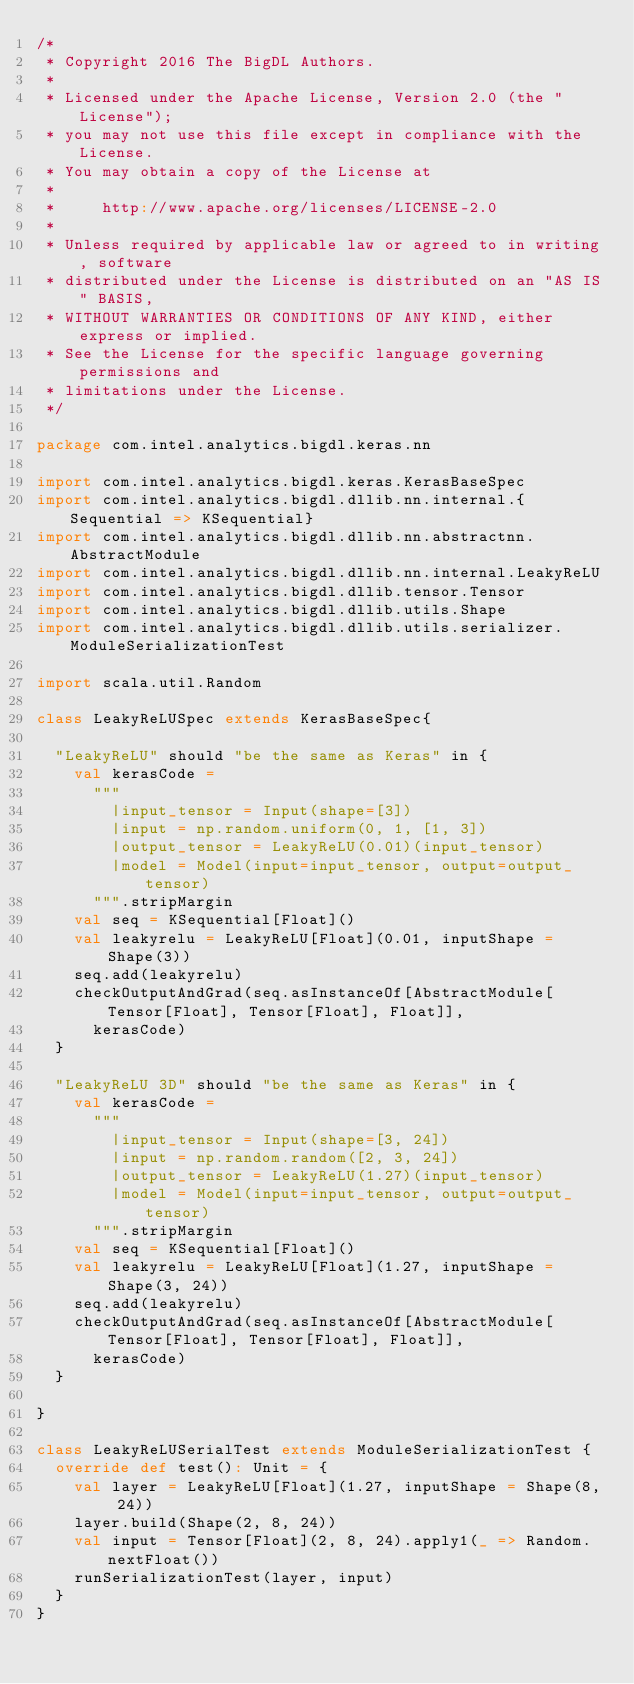<code> <loc_0><loc_0><loc_500><loc_500><_Scala_>/*
 * Copyright 2016 The BigDL Authors.
 *
 * Licensed under the Apache License, Version 2.0 (the "License");
 * you may not use this file except in compliance with the License.
 * You may obtain a copy of the License at
 *
 *     http://www.apache.org/licenses/LICENSE-2.0
 *
 * Unless required by applicable law or agreed to in writing, software
 * distributed under the License is distributed on an "AS IS" BASIS,
 * WITHOUT WARRANTIES OR CONDITIONS OF ANY KIND, either express or implied.
 * See the License for the specific language governing permissions and
 * limitations under the License.
 */

package com.intel.analytics.bigdl.keras.nn

import com.intel.analytics.bigdl.keras.KerasBaseSpec
import com.intel.analytics.bigdl.dllib.nn.internal.{Sequential => KSequential}
import com.intel.analytics.bigdl.dllib.nn.abstractnn.AbstractModule
import com.intel.analytics.bigdl.dllib.nn.internal.LeakyReLU
import com.intel.analytics.bigdl.dllib.tensor.Tensor
import com.intel.analytics.bigdl.dllib.utils.Shape
import com.intel.analytics.bigdl.dllib.utils.serializer.ModuleSerializationTest

import scala.util.Random

class LeakyReLUSpec extends KerasBaseSpec{

  "LeakyReLU" should "be the same as Keras" in {
    val kerasCode =
      """
        |input_tensor = Input(shape=[3])
        |input = np.random.uniform(0, 1, [1, 3])
        |output_tensor = LeakyReLU(0.01)(input_tensor)
        |model = Model(input=input_tensor, output=output_tensor)
      """.stripMargin
    val seq = KSequential[Float]()
    val leakyrelu = LeakyReLU[Float](0.01, inputShape = Shape(3))
    seq.add(leakyrelu)
    checkOutputAndGrad(seq.asInstanceOf[AbstractModule[Tensor[Float], Tensor[Float], Float]],
      kerasCode)
  }

  "LeakyReLU 3D" should "be the same as Keras" in {
    val kerasCode =
      """
        |input_tensor = Input(shape=[3, 24])
        |input = np.random.random([2, 3, 24])
        |output_tensor = LeakyReLU(1.27)(input_tensor)
        |model = Model(input=input_tensor, output=output_tensor)
      """.stripMargin
    val seq = KSequential[Float]()
    val leakyrelu = LeakyReLU[Float](1.27, inputShape = Shape(3, 24))
    seq.add(leakyrelu)
    checkOutputAndGrad(seq.asInstanceOf[AbstractModule[Tensor[Float], Tensor[Float], Float]],
      kerasCode)
  }

}

class LeakyReLUSerialTest extends ModuleSerializationTest {
  override def test(): Unit = {
    val layer = LeakyReLU[Float](1.27, inputShape = Shape(8, 24))
    layer.build(Shape(2, 8, 24))
    val input = Tensor[Float](2, 8, 24).apply1(_ => Random.nextFloat())
    runSerializationTest(layer, input)
  }
}
</code> 